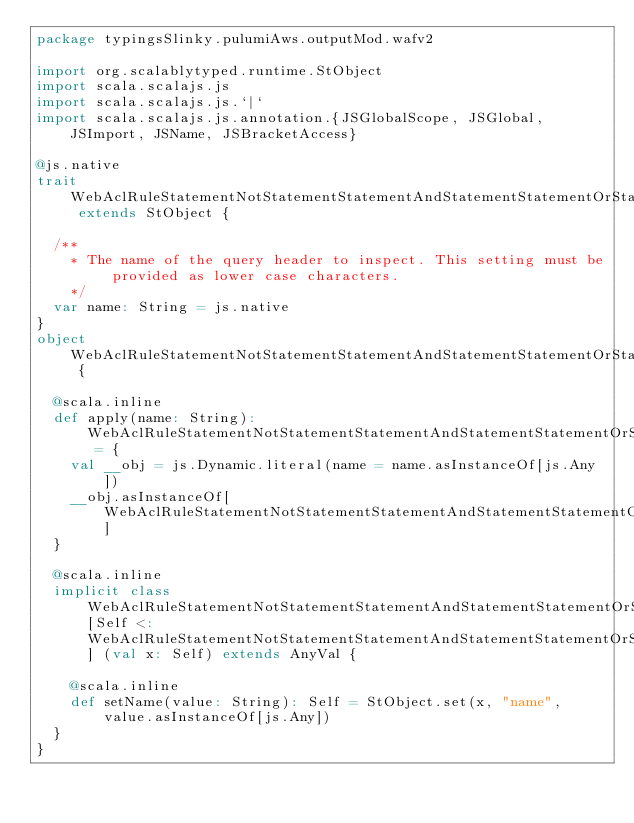<code> <loc_0><loc_0><loc_500><loc_500><_Scala_>package typingsSlinky.pulumiAws.outputMod.wafv2

import org.scalablytyped.runtime.StObject
import scala.scalajs.js
import scala.scalajs.js.`|`
import scala.scalajs.js.annotation.{JSGlobalScope, JSGlobal, JSImport, JSName, JSBracketAccess}

@js.native
trait WebAclRuleStatementNotStatementStatementAndStatementStatementOrStatementStatementSqliMatchStatementFieldToMatchSingleHeader extends StObject {
  
  /**
    * The name of the query header to inspect. This setting must be provided as lower case characters.
    */
  var name: String = js.native
}
object WebAclRuleStatementNotStatementStatementAndStatementStatementOrStatementStatementSqliMatchStatementFieldToMatchSingleHeader {
  
  @scala.inline
  def apply(name: String): WebAclRuleStatementNotStatementStatementAndStatementStatementOrStatementStatementSqliMatchStatementFieldToMatchSingleHeader = {
    val __obj = js.Dynamic.literal(name = name.asInstanceOf[js.Any])
    __obj.asInstanceOf[WebAclRuleStatementNotStatementStatementAndStatementStatementOrStatementStatementSqliMatchStatementFieldToMatchSingleHeader]
  }
  
  @scala.inline
  implicit class WebAclRuleStatementNotStatementStatementAndStatementStatementOrStatementStatementSqliMatchStatementFieldToMatchSingleHeaderMutableBuilder[Self <: WebAclRuleStatementNotStatementStatementAndStatementStatementOrStatementStatementSqliMatchStatementFieldToMatchSingleHeader] (val x: Self) extends AnyVal {
    
    @scala.inline
    def setName(value: String): Self = StObject.set(x, "name", value.asInstanceOf[js.Any])
  }
}
</code> 